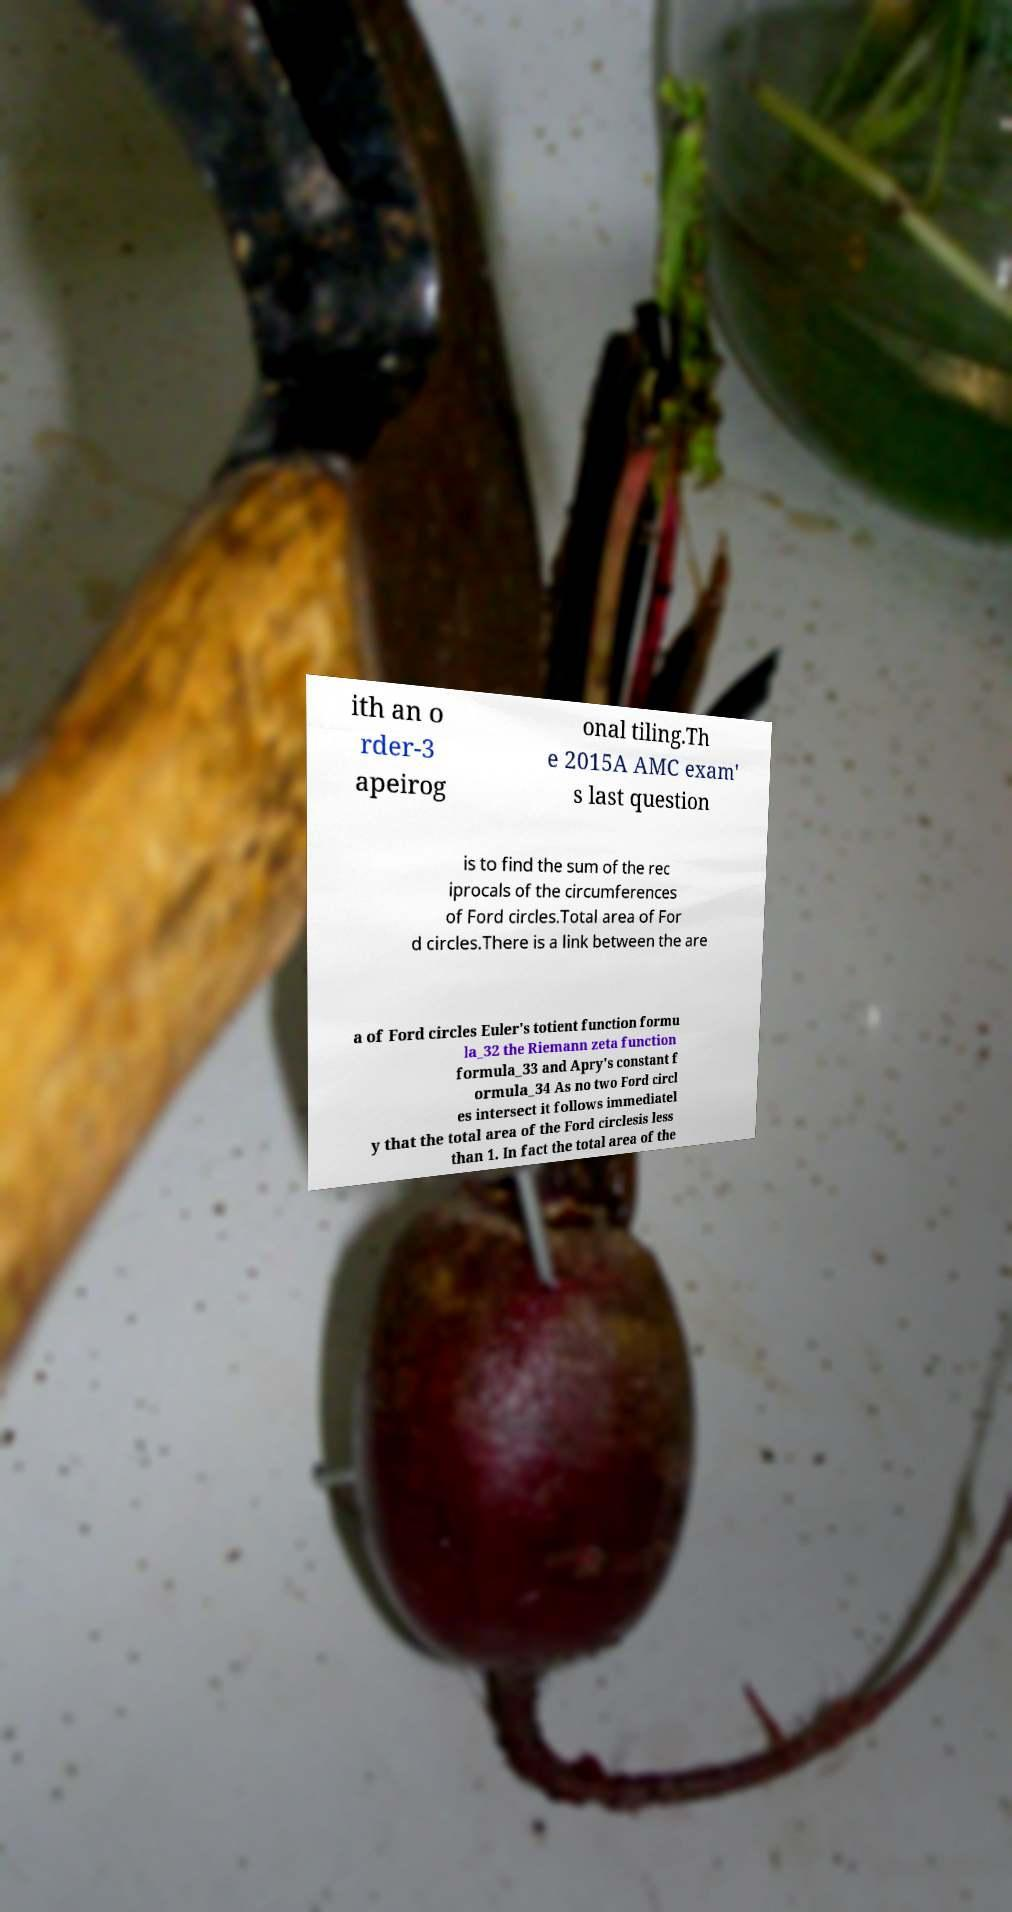Please identify and transcribe the text found in this image. ith an o rder-3 apeirog onal tiling.Th e 2015A AMC exam' s last question is to find the sum of the rec iprocals of the circumferences of Ford circles.Total area of For d circles.There is a link between the are a of Ford circles Euler's totient function formu la_32 the Riemann zeta function formula_33 and Apry's constant f ormula_34 As no two Ford circl es intersect it follows immediatel y that the total area of the Ford circlesis less than 1. In fact the total area of the 